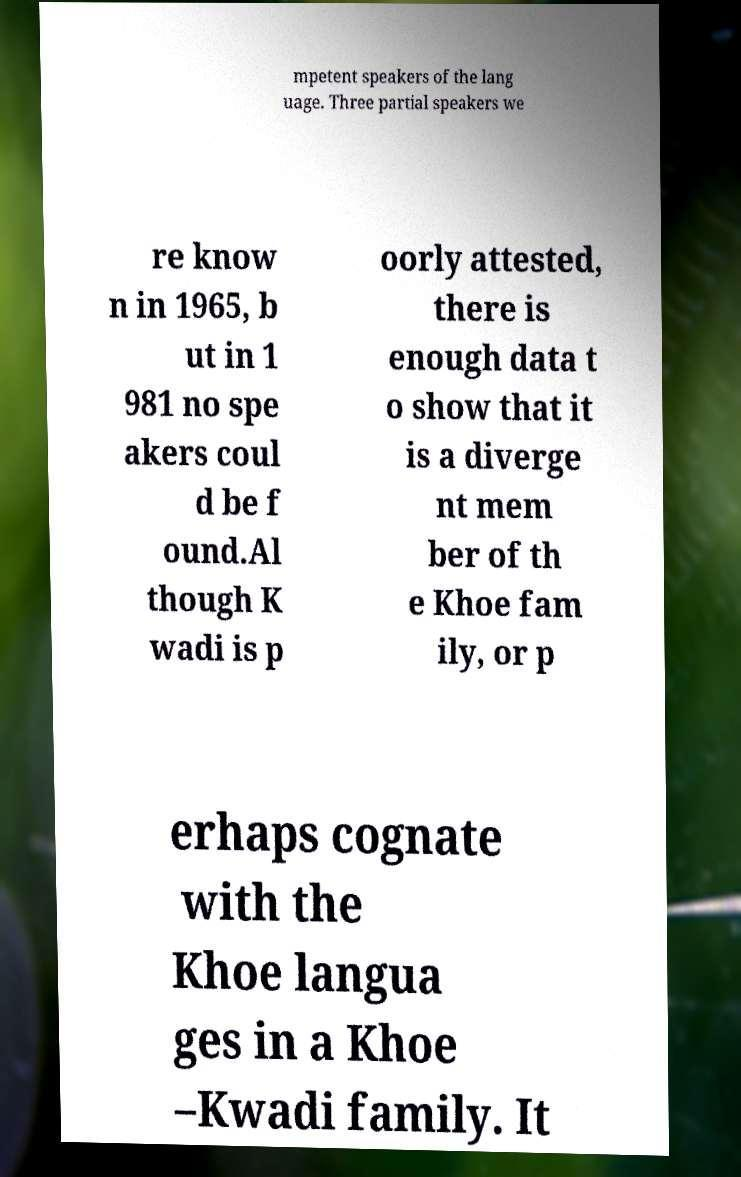For documentation purposes, I need the text within this image transcribed. Could you provide that? mpetent speakers of the lang uage. Three partial speakers we re know n in 1965, b ut in 1 981 no spe akers coul d be f ound.Al though K wadi is p oorly attested, there is enough data t o show that it is a diverge nt mem ber of th e Khoe fam ily, or p erhaps cognate with the Khoe langua ges in a Khoe –Kwadi family. It 